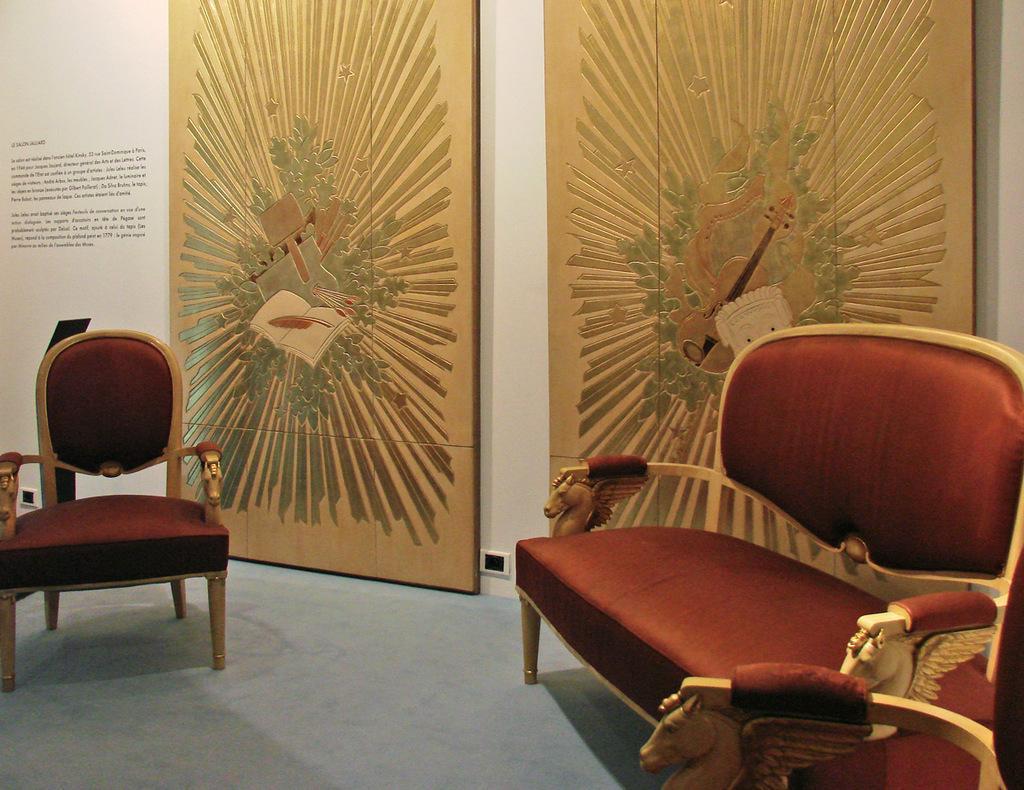Please provide a concise description of this image. In this image, there is a sofa in the right and a chair in the left. In the background there are two boards with some art printed on it. 